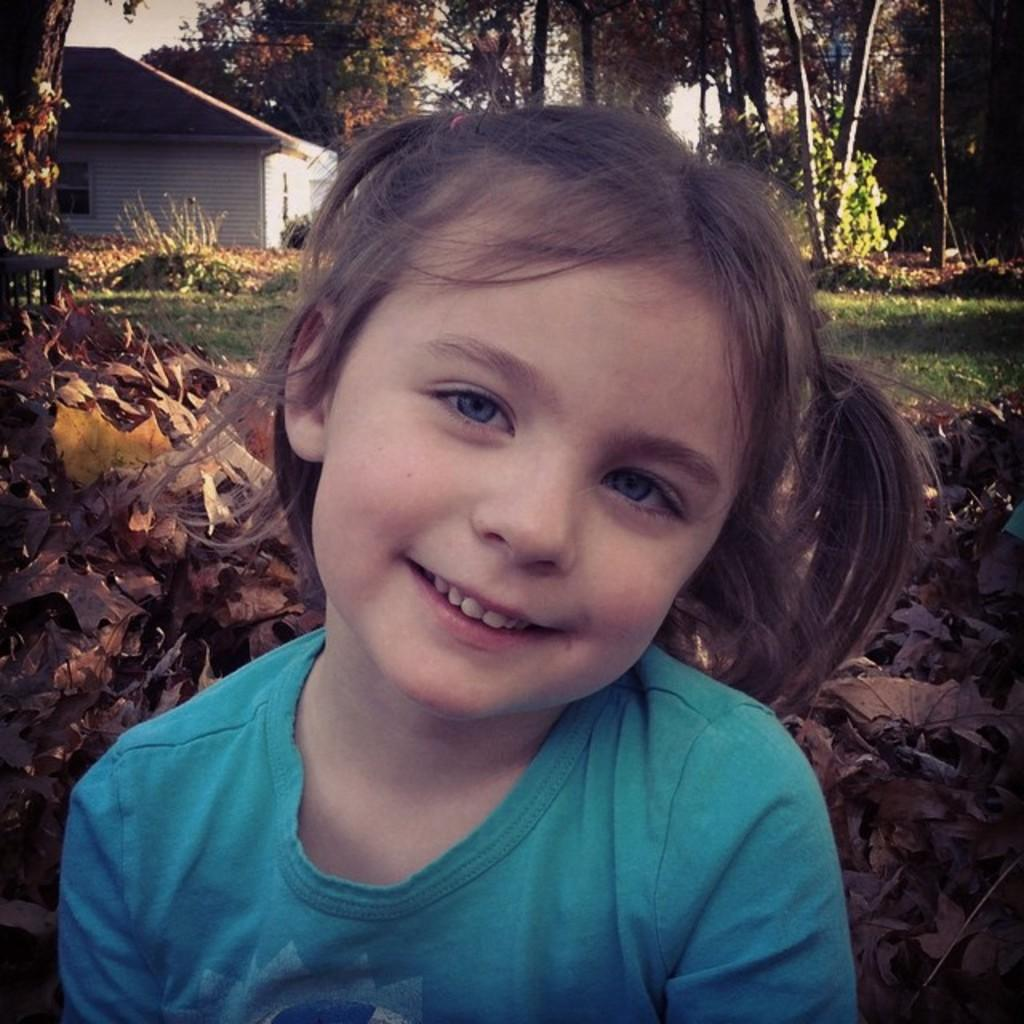Who is the main subject in the image? There is a girl in the image. What type of natural environment is visible in the background of the image? There is grassland in the background of the image. What other objects or structures can be seen in the background of the image? There are trees and a house in the background of the image. What type of pen is the girl using to write in the image? There is no pen present in the image, and the girl is not shown writing. What is the level of the house in the image? The level of the house cannot be determined from the image, as it only shows the house in the background. 